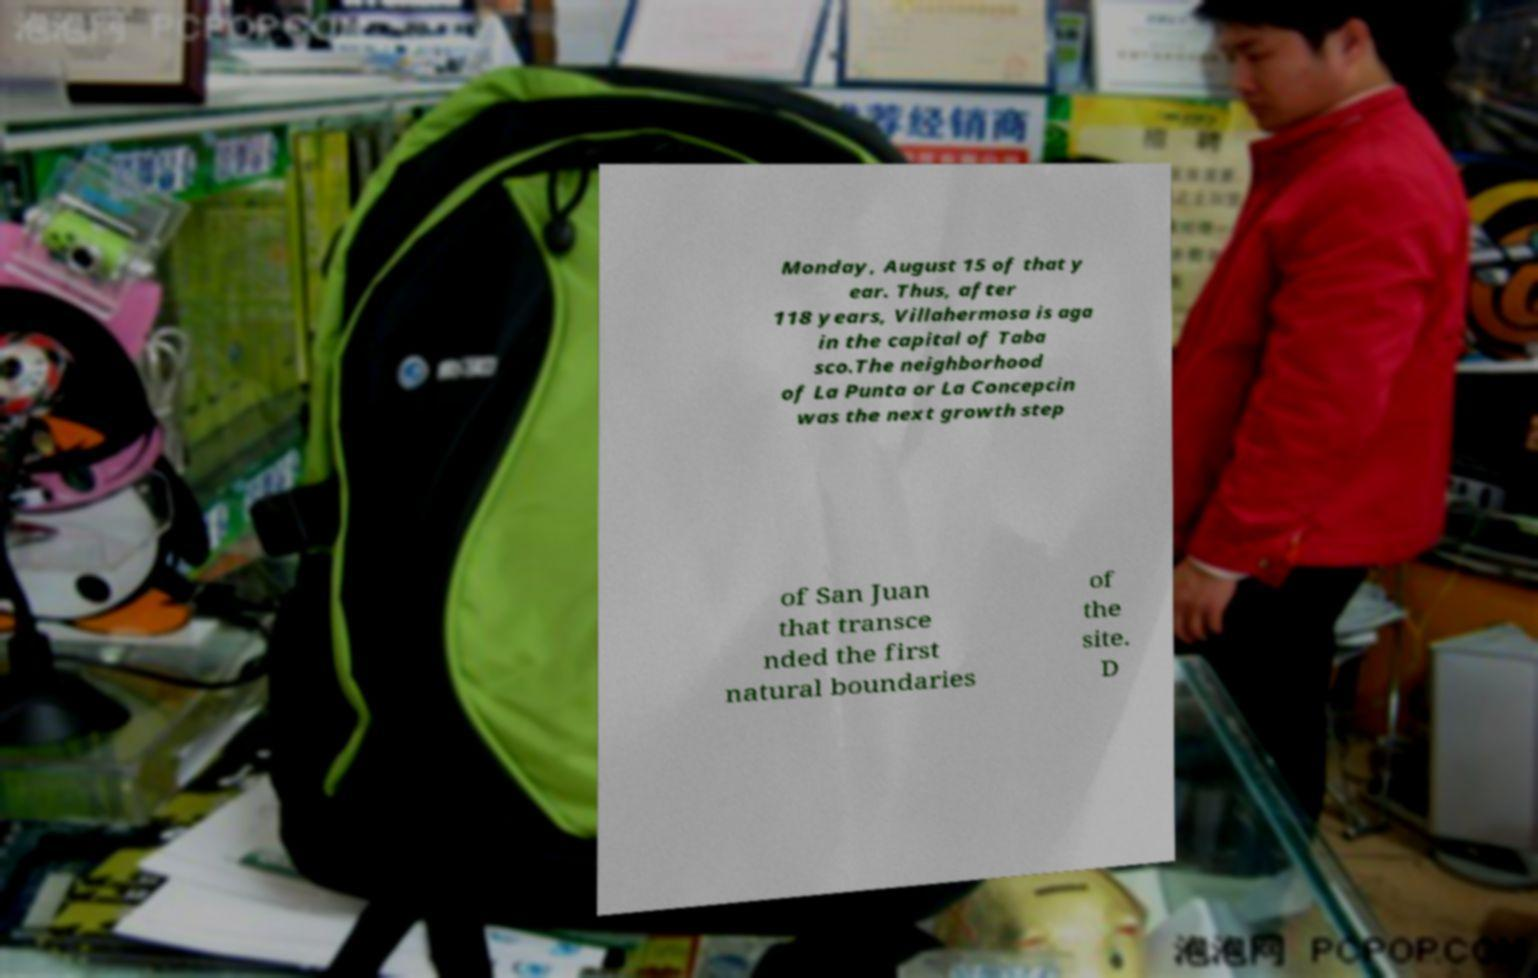Can you accurately transcribe the text from the provided image for me? Monday, August 15 of that y ear. Thus, after 118 years, Villahermosa is aga in the capital of Taba sco.The neighborhood of La Punta or La Concepcin was the next growth step of San Juan that transce nded the first natural boundaries of the site. D 